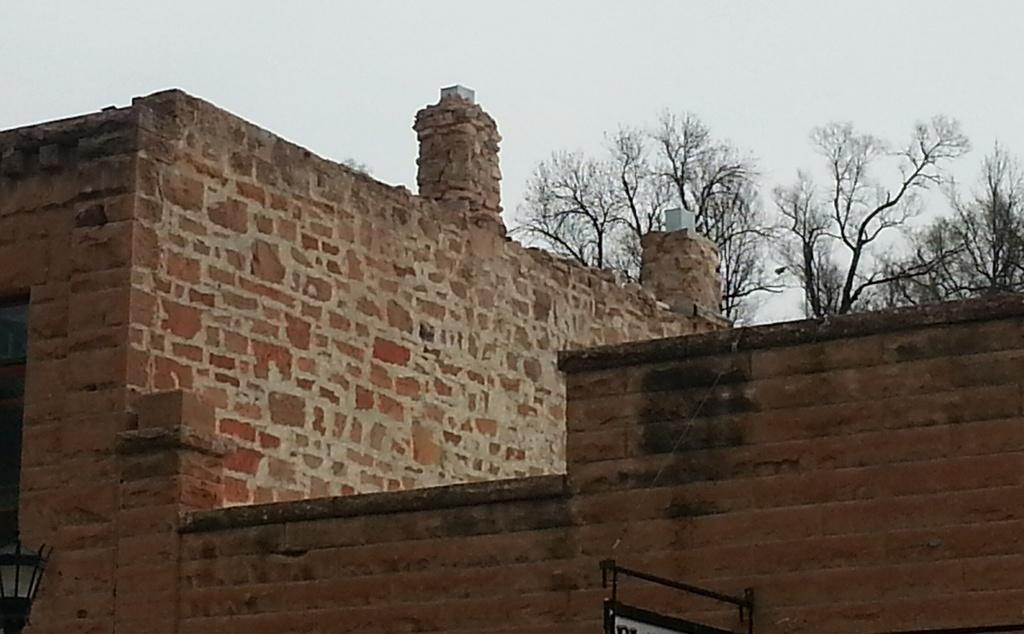Describe this image in one or two sentences. In this image I can see the wall and I can see the sky and tree at the top and a light visible at in the bottom left 